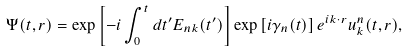<formula> <loc_0><loc_0><loc_500><loc_500>\Psi ( t , { r } ) = \exp \left [ - i \int _ { 0 } ^ { t } d t ^ { \prime } E _ { n k } ( t ^ { \prime } ) \right ] \exp \left [ i \gamma _ { n } ( t ) \right ] e ^ { i { k } \cdot { r } } u ^ { n } _ { k } ( t , { r } ) ,</formula> 